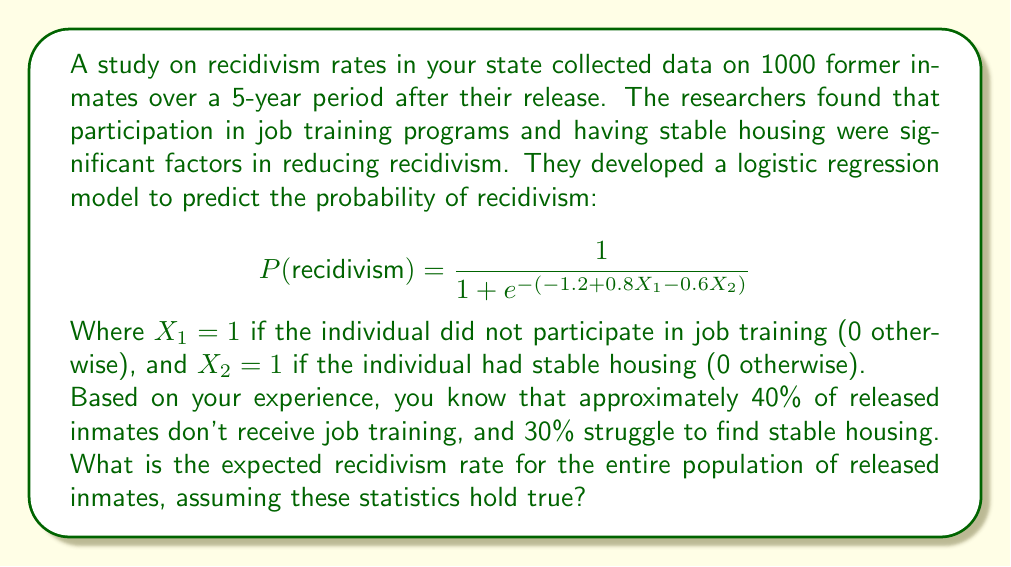Show me your answer to this math problem. To solve this problem, we need to follow these steps:

1. Identify the four possible combinations of job training and housing status.
2. Calculate the probability of recidivism for each combination.
3. Determine the proportion of the population in each category.
4. Calculate the weighted average of recidivism probabilities.

Step 1: Identify combinations
- Group A: No job training, No stable housing (X₁ = 1, X₂ = 0)
- Group B: No job training, Stable housing (X₁ = 1, X₂ = 1)
- Group C: Job training, No stable housing (X₁ = 0, X₂ = 0)
- Group D: Job training, Stable housing (X₁ = 0, X₂ = 1)

Step 2: Calculate recidivism probabilities
For each group, we plug the values into the logistic regression formula:

Group A: $$P_A = \frac{1}{1 + e^{-(-1.2 + 0.8(1) - 0.6(0))}} = \frac{1}{1 + e^{-(-0.4)}} = 0.5987$$

Group B: $$P_B = \frac{1}{1 + e^{-(-1.2 + 0.8(1) - 0.6(1))}} = \frac{1}{1 + e^{-(-1.0)}} = 0.2689$$

Group C: $$P_C = \frac{1}{1 + e^{-(-1.2 + 0.8(0) - 0.6(0))}} = \frac{1}{1 + e^{-(-1.2)}} = 0.2315$$

Group D: $$P_D = \frac{1}{1 + e^{-(-1.2 + 0.8(0) - 0.6(1))}} = \frac{1}{1 + e^{-(-1.8)}} = 0.1423$$

Step 3: Determine population proportions
- 40% don't receive job training, 60% do
- 30% don't have stable housing, 70% do

Group A: 40% * 30% = 12%
Group B: 40% * 70% = 28%
Group C: 60% * 30% = 18%
Group D: 60% * 70% = 42%

Step 4: Calculate weighted average
Expected recidivism rate = (0.12 * 0.5987) + (0.28 * 0.2689) + (0.18 * 0.2315) + (0.42 * 0.1423)
= 0.07184 + 0.07529 + 0.04167 + 0.05977
= 0.24857
Answer: The expected recidivism rate for the entire population of released inmates is approximately 24.86%. 